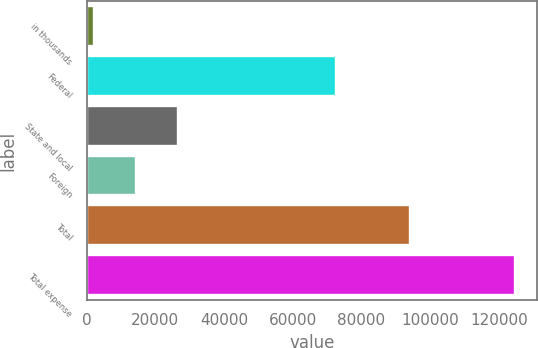Convert chart to OTSL. <chart><loc_0><loc_0><loc_500><loc_500><bar_chart><fcel>in thousands<fcel>Federal<fcel>State and local<fcel>Foreign<fcel>Total<fcel>Total expense<nl><fcel>2016<fcel>72506<fcel>26583<fcel>14299.5<fcel>94254<fcel>124851<nl></chart> 